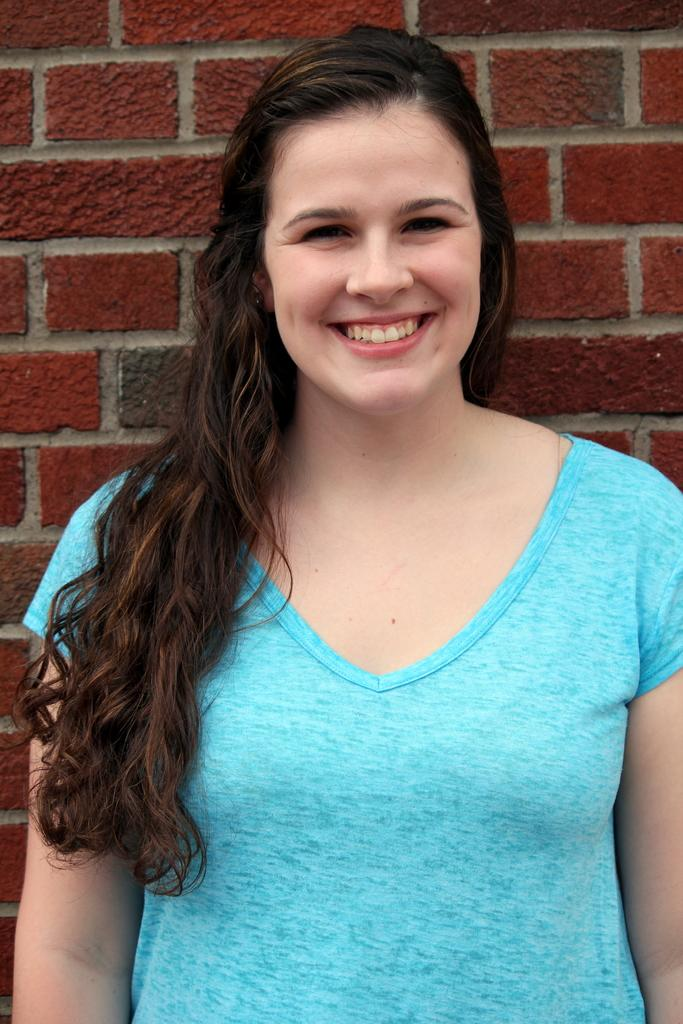Who is present in the image? There is a woman in the image. What is the woman doing in the image? The woman is standing and smiling. What is the woman wearing in the image? The woman is wearing a blue T-shirt. What can be seen in the background of the image? There is a wall with a brick texture in the image. What rule does the coach enforce in the image? There is no coach or rule present in the image. Where is the spot where the woman is standing in the image? The woman is standing on the ground, but there is no specific spot mentioned in the image. 